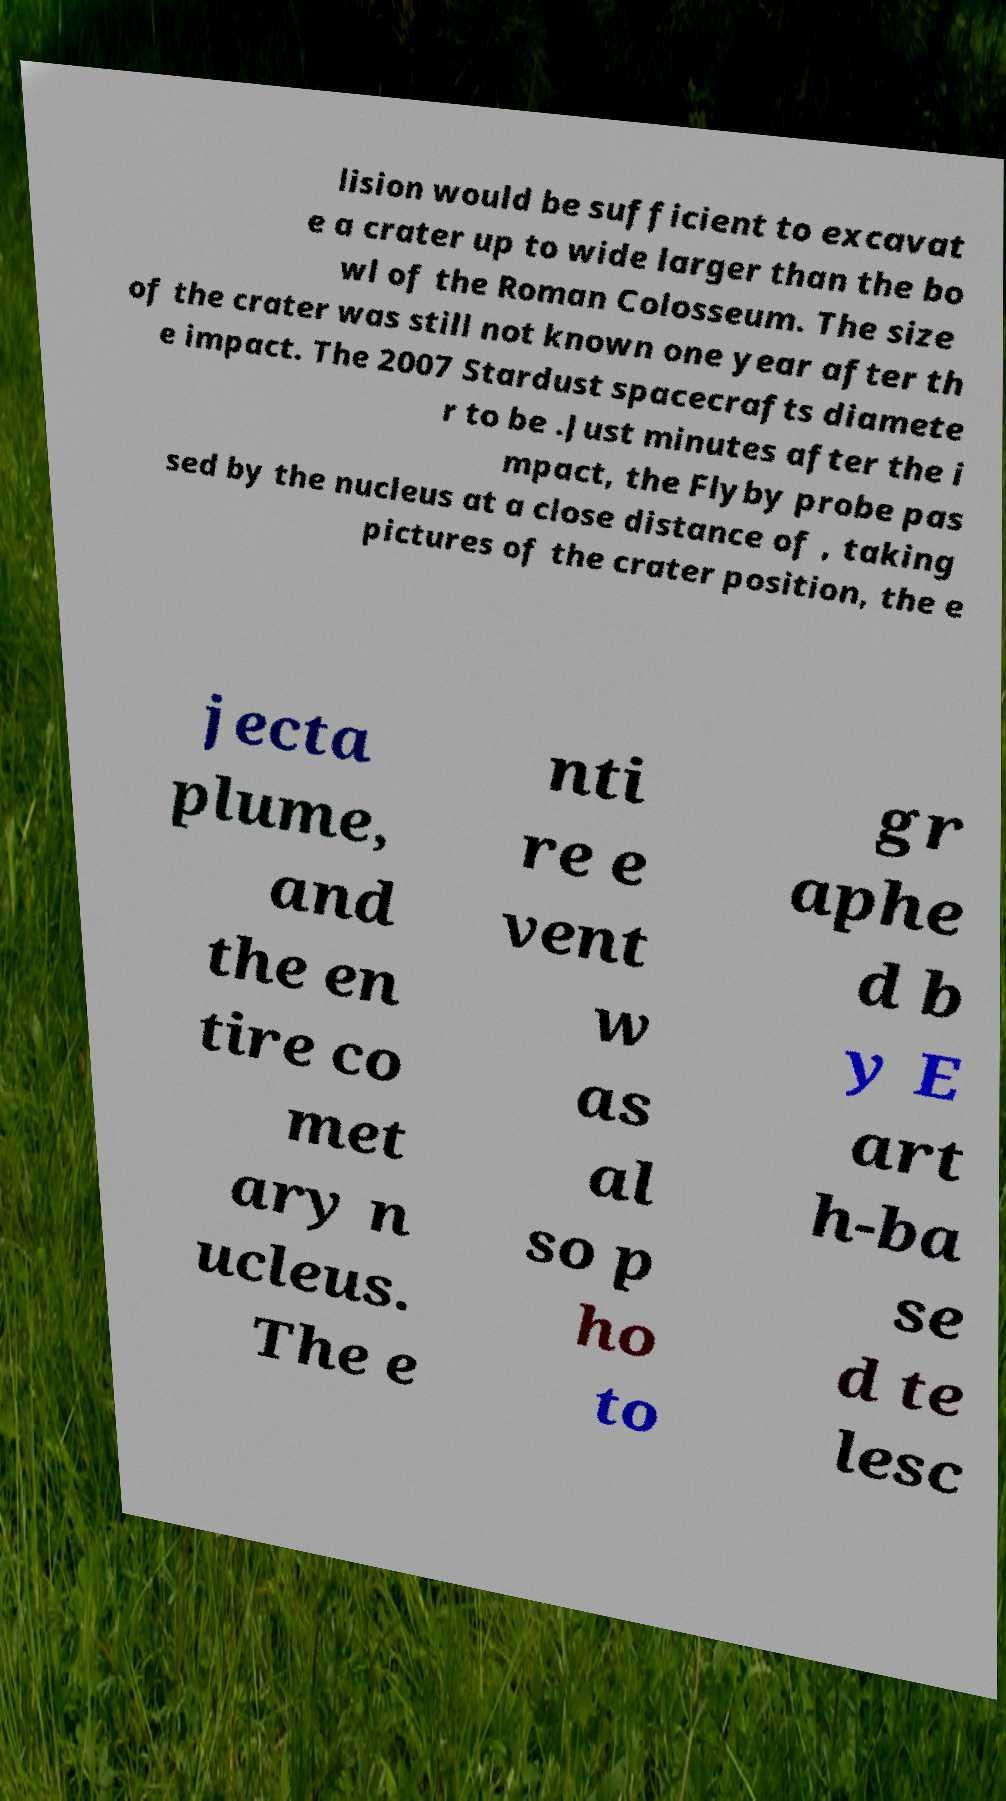What messages or text are displayed in this image? I need them in a readable, typed format. lision would be sufficient to excavat e a crater up to wide larger than the bo wl of the Roman Colosseum. The size of the crater was still not known one year after th e impact. The 2007 Stardust spacecrafts diamete r to be .Just minutes after the i mpact, the Flyby probe pas sed by the nucleus at a close distance of , taking pictures of the crater position, the e jecta plume, and the en tire co met ary n ucleus. The e nti re e vent w as al so p ho to gr aphe d b y E art h-ba se d te lesc 